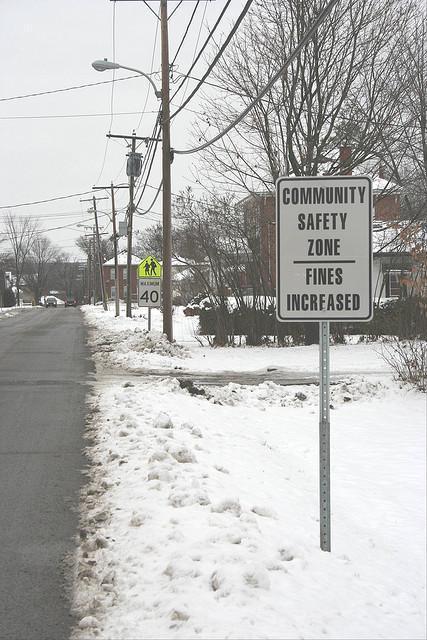How many people are wearing a yellow shirt in the image?
Give a very brief answer. 0. 